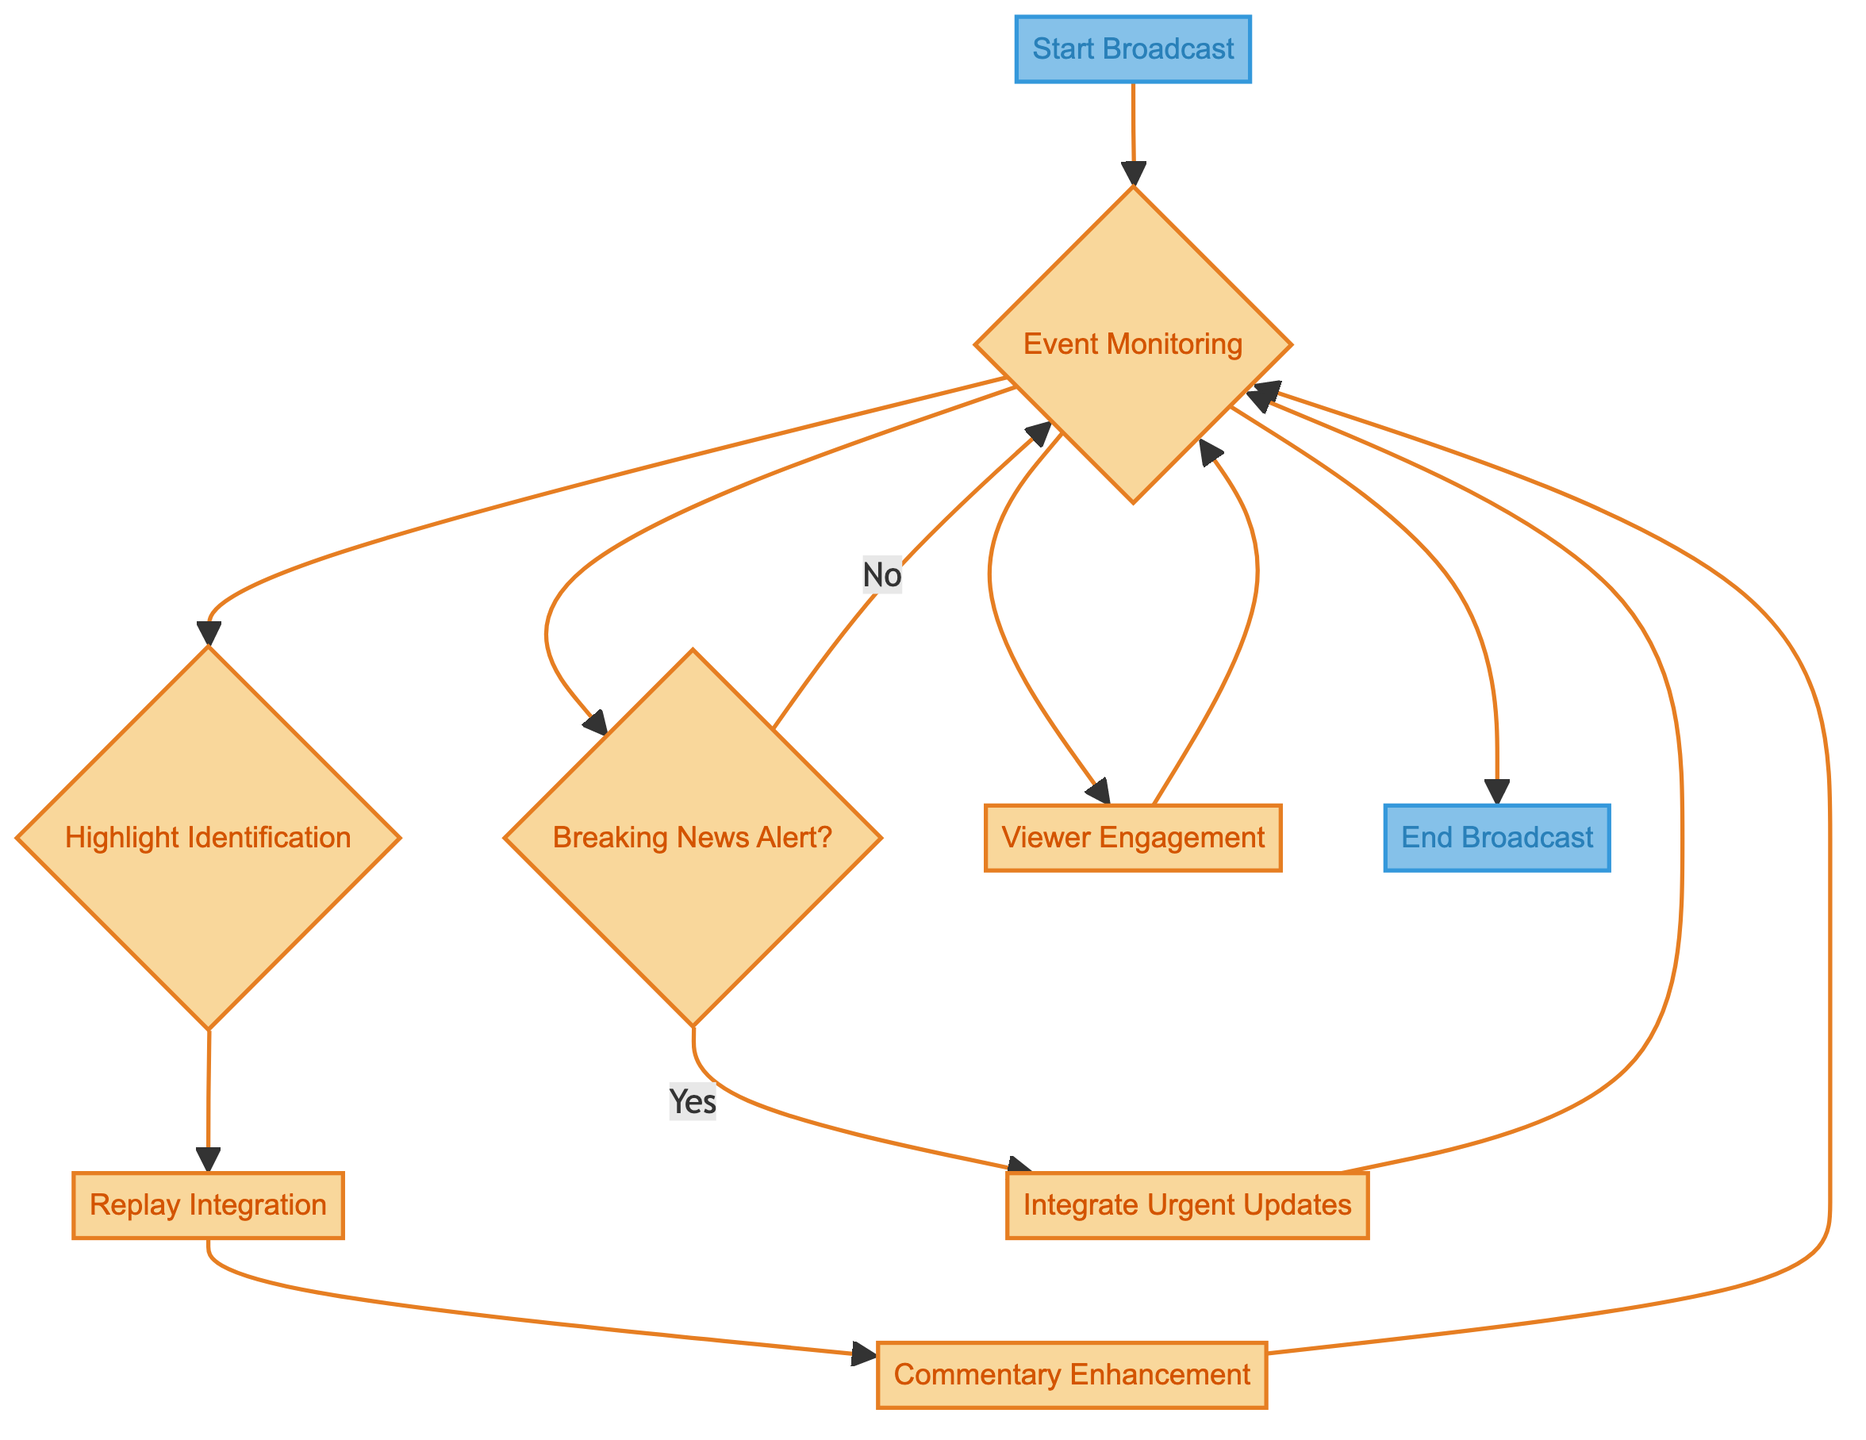What is the first step in the broadcast process? The diagram starts with the "Start Broadcast" node, which initiates the live feed.
Answer: Start Broadcast How many main steps are there in the process? The diagram lists a total of eight distinct steps from "Start Broadcast" to "End Broadcast."
Answer: Eight What action follows the "Highlight Identification"? After "Highlight Identification," the next action is "Replay Integration."
Answer: Replay Integration Which step allows for live audience interaction? The step that allows for interaction with the audience is "Viewer Engagement."
Answer: Viewer Engagement If there is breaking news, which node is activated? If there is breaking news, the "Breaking News Alert" node is activated, leading to the integration of urgent updates.
Answer: Integrate Urgent Updates What loop is present in the process? The process contains a loop from "Commentary Enhancement" back to "Event Monitoring."
Answer: Commentary Enhancement to Event Monitoring How does the process conclude? The process concludes with the "End Broadcast" step, which signals the completion of the live feed.
Answer: End Broadcast Which tools are needed to start the broadcast? The tools required to start the broadcast are "Broadcast Software," "Microphone," and "Camera."
Answer: Broadcast Software, Microphone, Camera What triggers the viewer engagement action? The action for viewer engagement is triggered after the "Event Monitoring" step, allowing for interaction with the audience.
Answer: Event Monitoring 